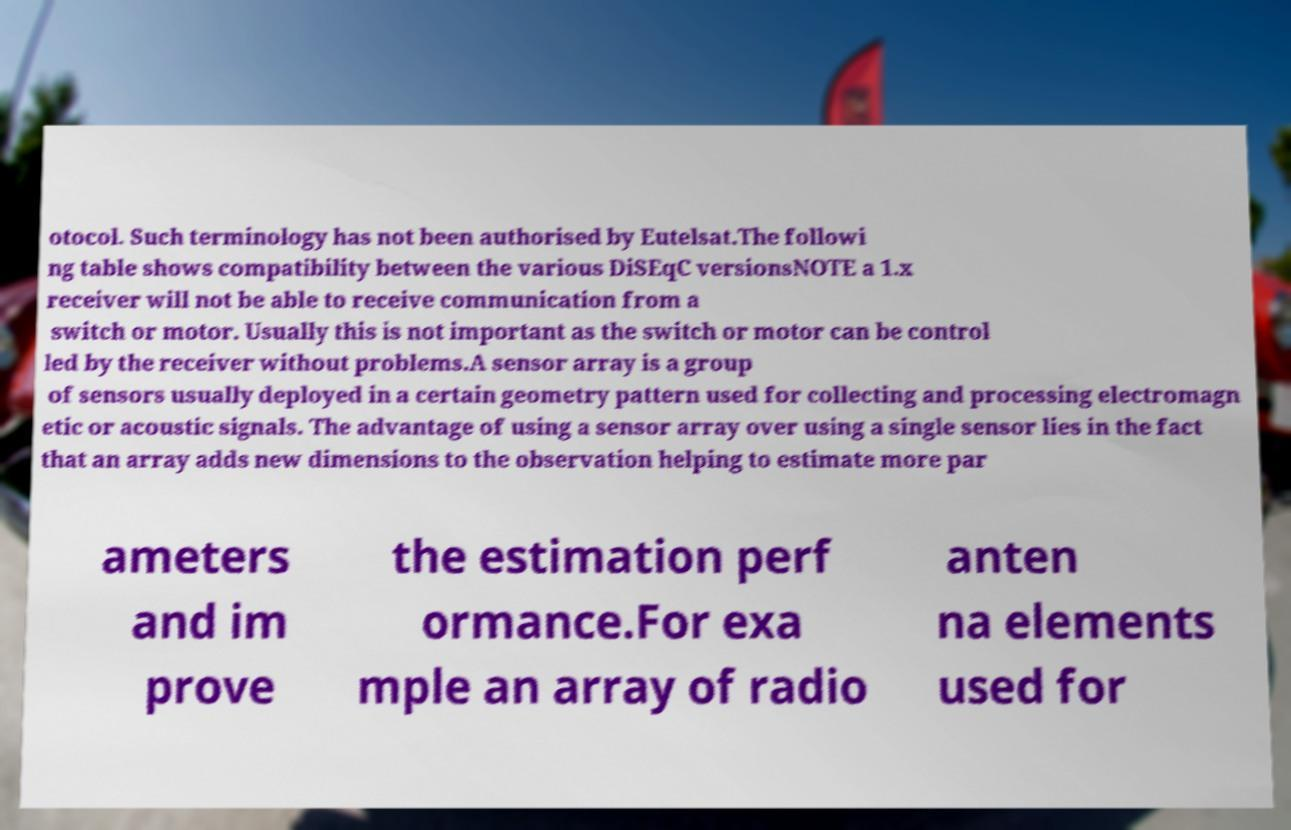There's text embedded in this image that I need extracted. Can you transcribe it verbatim? otocol. Such terminology has not been authorised by Eutelsat.The followi ng table shows compatibility between the various DiSEqC versionsNOTE a 1.x receiver will not be able to receive communication from a switch or motor. Usually this is not important as the switch or motor can be control led by the receiver without problems.A sensor array is a group of sensors usually deployed in a certain geometry pattern used for collecting and processing electromagn etic or acoustic signals. The advantage of using a sensor array over using a single sensor lies in the fact that an array adds new dimensions to the observation helping to estimate more par ameters and im prove the estimation perf ormance.For exa mple an array of radio anten na elements used for 